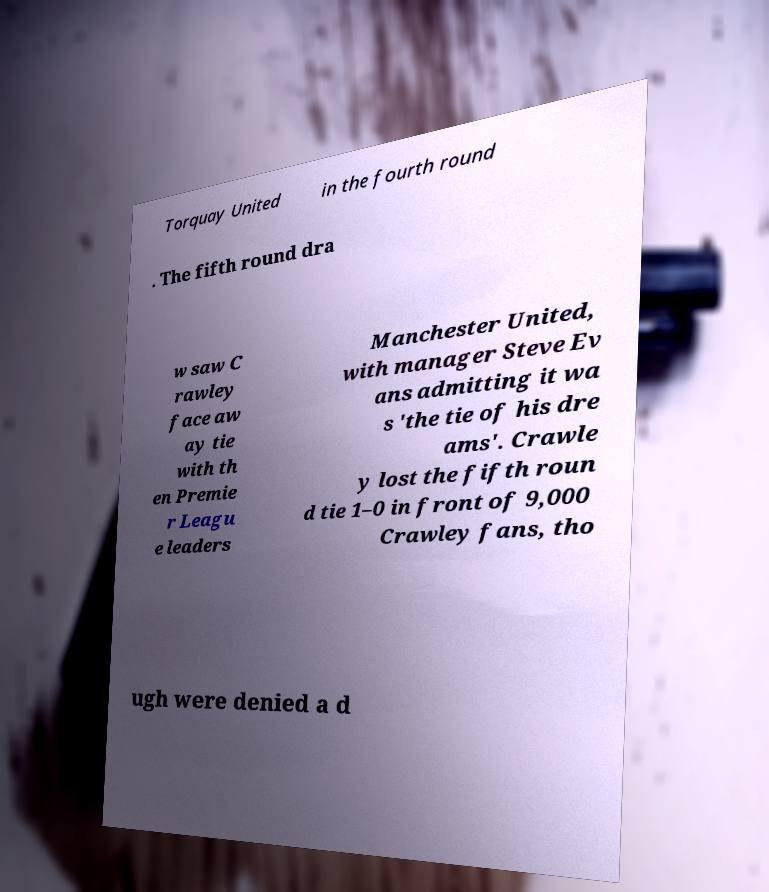Could you assist in decoding the text presented in this image and type it out clearly? Torquay United in the fourth round . The fifth round dra w saw C rawley face aw ay tie with th en Premie r Leagu e leaders Manchester United, with manager Steve Ev ans admitting it wa s 'the tie of his dre ams'. Crawle y lost the fifth roun d tie 1–0 in front of 9,000 Crawley fans, tho ugh were denied a d 